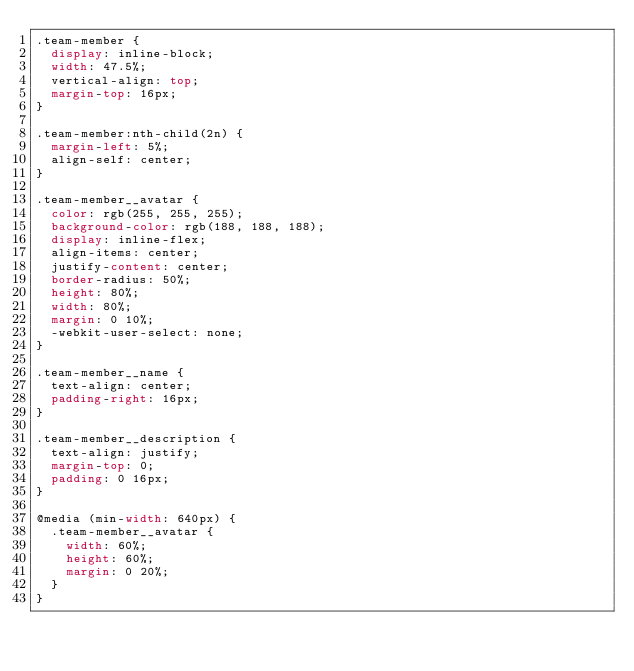Convert code to text. <code><loc_0><loc_0><loc_500><loc_500><_CSS_>.team-member {
	display: inline-block;
	width: 47.5%;
	vertical-align: top;
	margin-top: 16px;
}

.team-member:nth-child(2n) {
	margin-left: 5%;
	align-self: center;
}

.team-member__avatar {
	color: rgb(255, 255, 255);
	background-color: rgb(188, 188, 188);
	display: inline-flex;
	align-items: center;
	justify-content: center;
	border-radius: 50%;
	height: 80%;
	width: 80%;
	margin: 0 10%;
	-webkit-user-select: none;
}

.team-member__name {
	text-align: center;
	padding-right: 16px;
}

.team-member__description {
	text-align: justify;
	margin-top: 0;
	padding: 0 16px;
}

@media (min-width: 640px) {
	.team-member__avatar {
		width: 60%;
		height: 60%;
		margin: 0 20%;
	}
}
</code> 